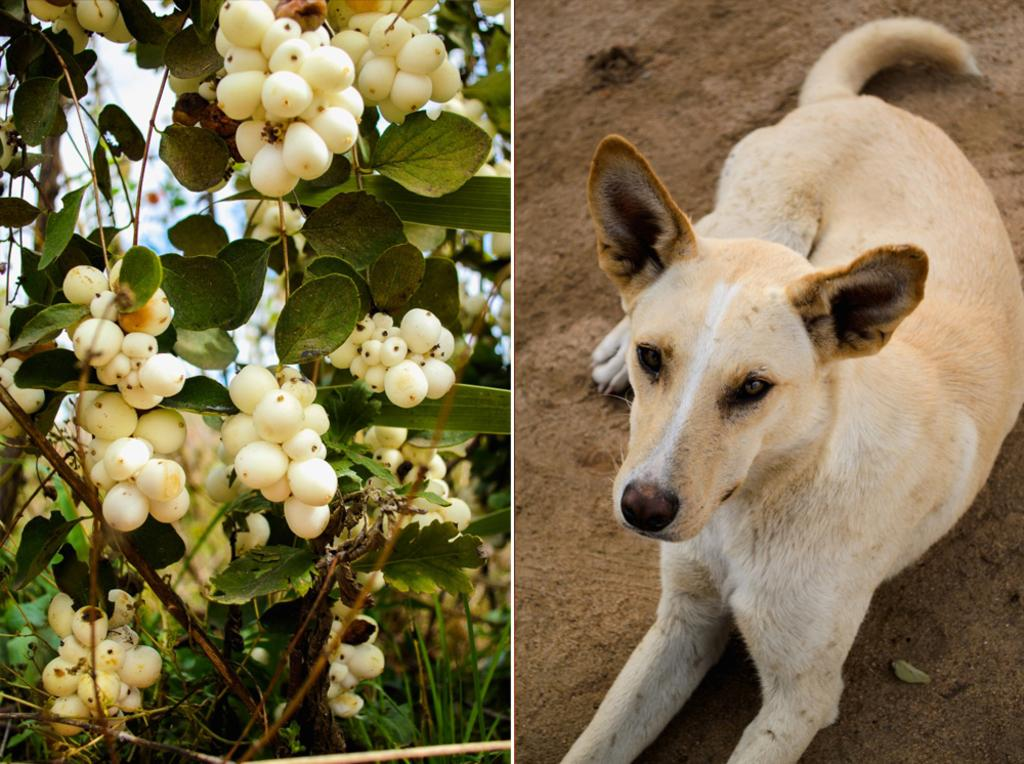What type of artwork is shown in the image? The image is a collage. What animal can be seen in the image? There is a dog in the image. Where is the dog located in the image? The dog is on the ground. What colors can be seen on the dog? The dog has cream, white, and brown colors. What other objects are present in the image besides the dog? There are fruits in the image. Where are the fruits located in relation to the plants? The fruits are near plants. How many visitors are waiting at the airport in the image? There is no airport or visitors present in the image; it is a collage featuring a dog, fruits, and plants. 